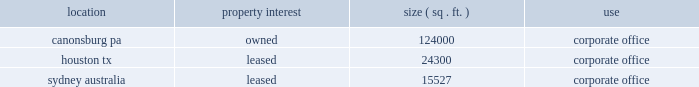We have experienced disputes with customers and suppliers 2014such disputes may lead to increased tensions , damaged relationships or litigation which may result in the loss of a key customer or supplier .
We have experienced certain conflicts or disputes with some of our customers and service providers .
Most of these disputes relate to the interpretation of terms in our contracts .
While we seek to resolve such conflicts amicably and have generally resolved customer and supplier disputes on commercially reasonable terms , such disputes may lead to increased tensions and damaged relationships between ourselves and these entities , some of whom are key customers or suppliers of ours .
In addition , if we are unable to resolve these differences amicably , we may be forced to litigate these disputes in order to enforce or defend our rights .
There can be no assurances as to the outcome of these disputes .
Damaged relationships or litigation with our key customers or suppliers may lead to decreased revenues ( including as a result of losing a customer ) or increased costs , which could have a material adverse effect on us .
Our operations in australia expose us to changes in foreign currency exchange rates 2014we may suffer losses as a result of changes in such currency exchange rates .
We conduct business in the u.s .
And australia , which exposes us to fluctuations in foreign currency exchange rates .
For the year ended december 31 , 2004 , approximately 7.5% ( 7.5 % ) of our consolidated revenues originated outside the u.s. , all of which were denominated in currencies other than u.s .
Dollars , principally australian dollars .
We have not historically engaged in significant hedging activities relating to our non-u.s .
Dollar operations , and we may suffer future losses as a result of changes in currency exchange rates .
Internet access to reports we maintain an internet website at www.crowncastle.com .
Our annual reports on form 10-k , quarterly reports on form 10-q , and current reports on form 8-k ( and any amendments to those reports filed or furnished pursuant to section 13 ( a ) or 15 ( d ) of the securities exchange act of 1934 ) are made available , free of charge , through the investor relations section of our internet website at http://investor.crowncastle.com/edgar.cfm as soon as reasonably practicable after we electronically file such material with , or furnish it to , the securities and exchange commission .
In addition , our corporate governance guidelines , business practices and ethics policy and the charters of our audit committee , compensation committee and nominating & corporate governance committees are available through the investor relations section of our internet website at http://investor.crowncastle.com/edgar.cfm , and such information is also available in print to any shareholder who requests it .
Item 2 .
Properties our principal corporate offices are located in houston , texas ; canonsburg , pennsylvania ; and sydney , australia .
Location property interest ( sq .
Ft. ) use .
In the u.s. , we also lease and maintain five additional regional offices ( called 201carea offices 201d ) located in ( 1 ) albany , new york , ( 2 ) alpharetta , georgia , ( 3 ) charlotte , north carolina , ( 4 ) louisville , kentucky and ( 5 ) phoenix , arizona .
The principal responsibilities of these offices are to manage the leasing of tower space on a local basis , maintain the towers already located in the region and service our customers in the area .
As of december 31 , 2004 , 8816 of the sites on which our u.s .
Towers are located , or approximately 83% ( 83 % ) of our u.s .
Portfolio , were leased , subleased or licensed , while 1796 or approximately 17% ( 17 % ) were owned in fee or through .
About how many towers were leased or subleased in 2004? 
Rationale: the total number of towers in the us are given in line 24 . to find the amount leased we multiple that by the percentage given in line 25 .
Computations: (8816 * 83%)
Answer: 7317.28. We have experienced disputes with customers and suppliers 2014such disputes may lead to increased tensions , damaged relationships or litigation which may result in the loss of a key customer or supplier .
We have experienced certain conflicts or disputes with some of our customers and service providers .
Most of these disputes relate to the interpretation of terms in our contracts .
While we seek to resolve such conflicts amicably and have generally resolved customer and supplier disputes on commercially reasonable terms , such disputes may lead to increased tensions and damaged relationships between ourselves and these entities , some of whom are key customers or suppliers of ours .
In addition , if we are unable to resolve these differences amicably , we may be forced to litigate these disputes in order to enforce or defend our rights .
There can be no assurances as to the outcome of these disputes .
Damaged relationships or litigation with our key customers or suppliers may lead to decreased revenues ( including as a result of losing a customer ) or increased costs , which could have a material adverse effect on us .
Our operations in australia expose us to changes in foreign currency exchange rates 2014we may suffer losses as a result of changes in such currency exchange rates .
We conduct business in the u.s .
And australia , which exposes us to fluctuations in foreign currency exchange rates .
For the year ended december 31 , 2004 , approximately 7.5% ( 7.5 % ) of our consolidated revenues originated outside the u.s. , all of which were denominated in currencies other than u.s .
Dollars , principally australian dollars .
We have not historically engaged in significant hedging activities relating to our non-u.s .
Dollar operations , and we may suffer future losses as a result of changes in currency exchange rates .
Internet access to reports we maintain an internet website at www.crowncastle.com .
Our annual reports on form 10-k , quarterly reports on form 10-q , and current reports on form 8-k ( and any amendments to those reports filed or furnished pursuant to section 13 ( a ) or 15 ( d ) of the securities exchange act of 1934 ) are made available , free of charge , through the investor relations section of our internet website at http://investor.crowncastle.com/edgar.cfm as soon as reasonably practicable after we electronically file such material with , or furnish it to , the securities and exchange commission .
In addition , our corporate governance guidelines , business practices and ethics policy and the charters of our audit committee , compensation committee and nominating & corporate governance committees are available through the investor relations section of our internet website at http://investor.crowncastle.com/edgar.cfm , and such information is also available in print to any shareholder who requests it .
Item 2 .
Properties our principal corporate offices are located in houston , texas ; canonsburg , pennsylvania ; and sydney , australia .
Location property interest ( sq .
Ft. ) use .
In the u.s. , we also lease and maintain five additional regional offices ( called 201carea offices 201d ) located in ( 1 ) albany , new york , ( 2 ) alpharetta , georgia , ( 3 ) charlotte , north carolina , ( 4 ) louisville , kentucky and ( 5 ) phoenix , arizona .
The principal responsibilities of these offices are to manage the leasing of tower space on a local basis , maintain the towers already located in the region and service our customers in the area .
As of december 31 , 2004 , 8816 of the sites on which our u.s .
Towers are located , or approximately 83% ( 83 % ) of our u.s .
Portfolio , were leased , subleased or licensed , while 1796 or approximately 17% ( 17 % ) were owned in fee or through .
About how many towers were leased or subleased in 2004? 
Rationale: the total number of towers in the us are given in line 24 . to find the amount leased we multiple that by the percentage given in line 25 .
Computations: (8816 * 83%)
Answer: 7317.28. 